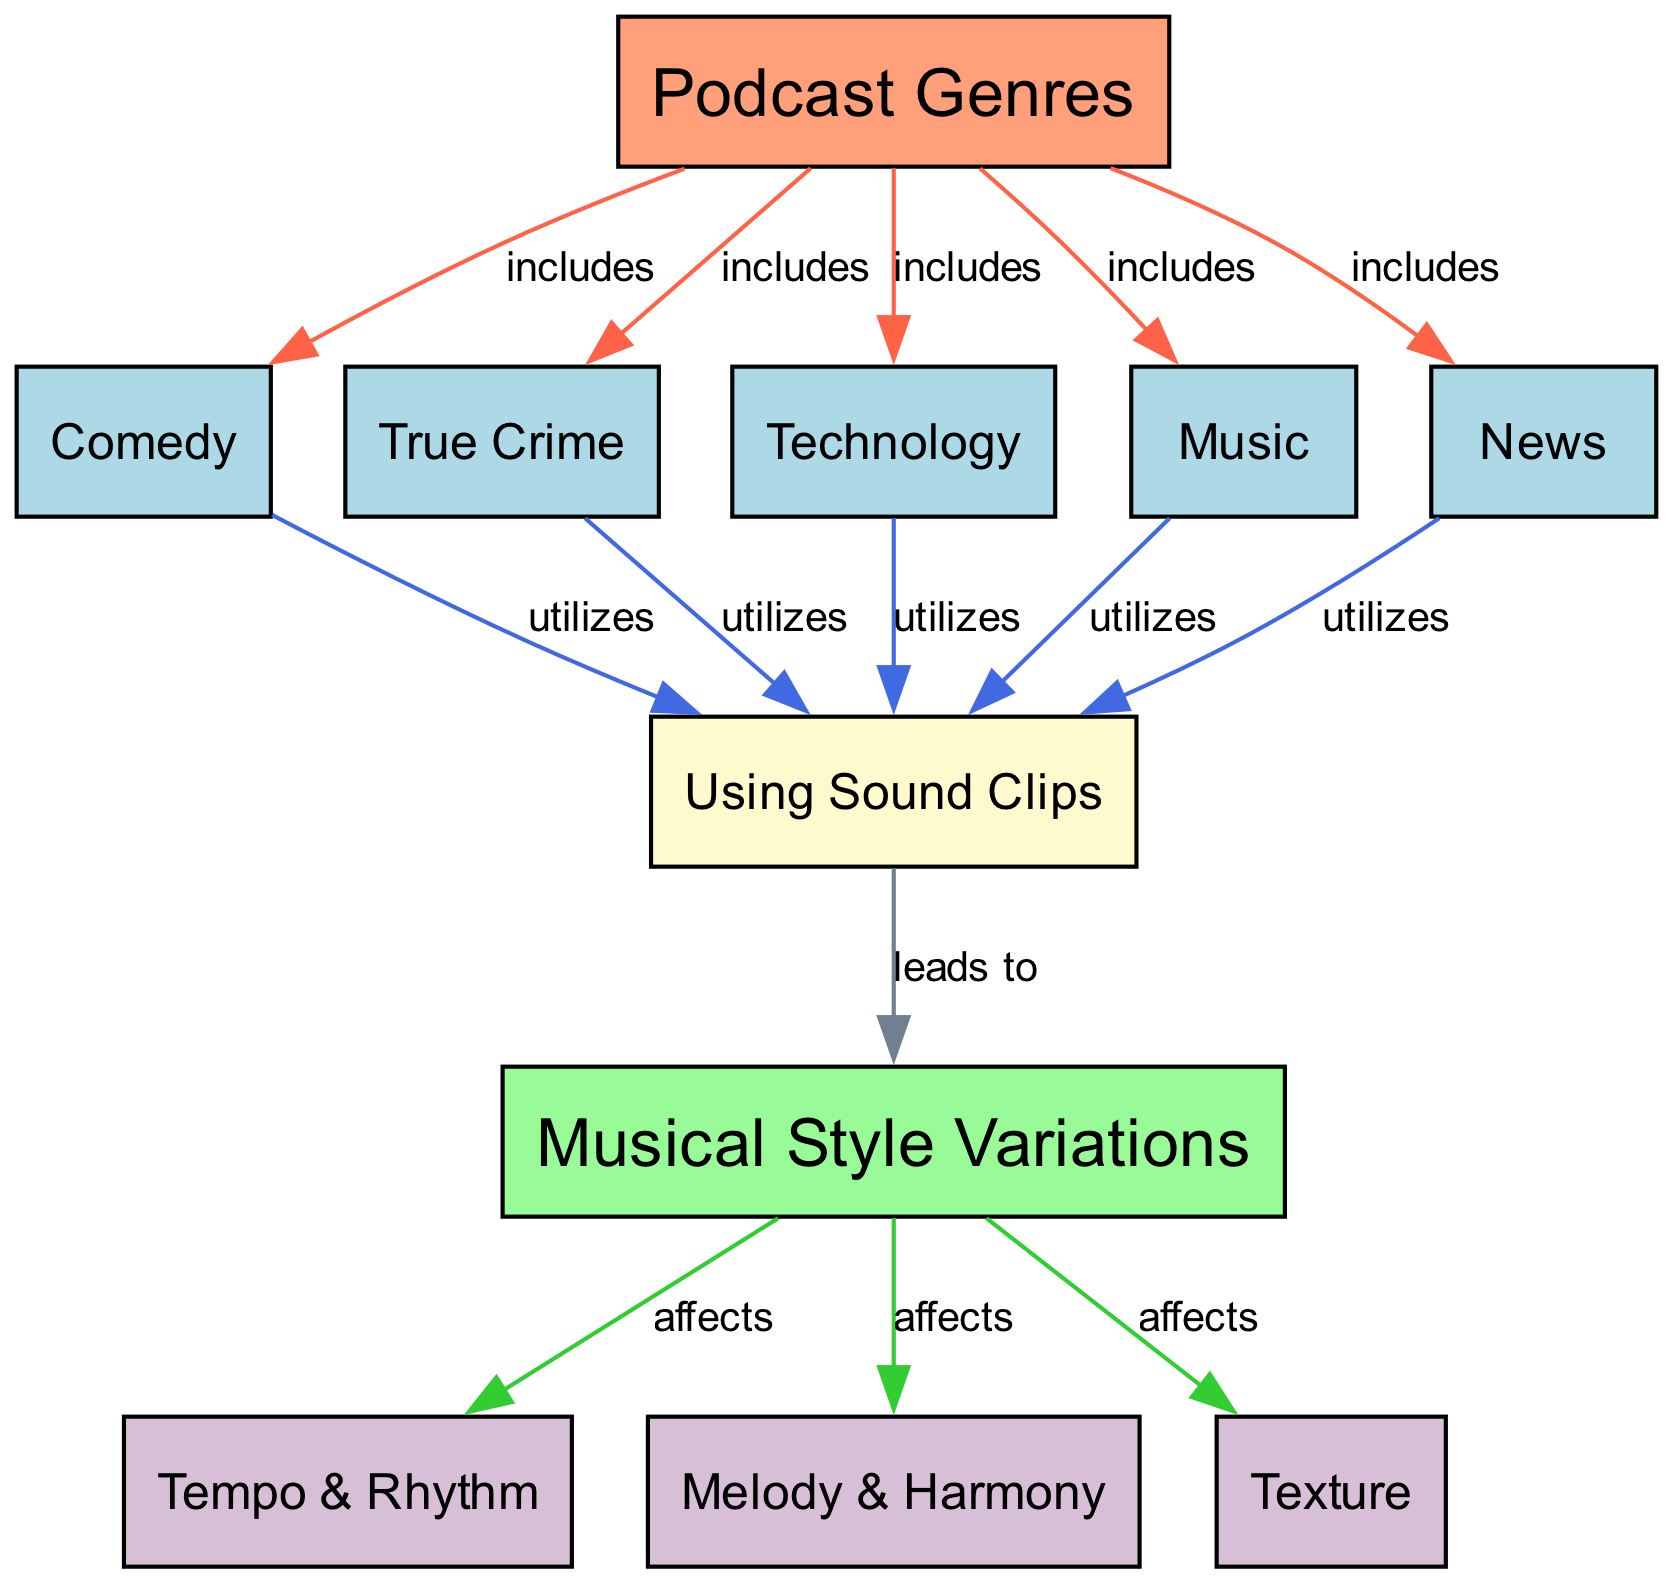What are the main podcast genres listed in the diagram? The diagram lists five main podcast genres, which are Comedy, True Crime, Technology, Music, and News. This information can be found in the nodes directly connected to the Podcast Genres node.
Answer: Comedy, True Crime, Technology, Music, News How many musical style variations are influenced by the podcast genres? There are three musical style variations: Tempo & Rhythm, Melody & Harmony, and Texture. These can be found in the nodes that are influenced by the Musical Style Variations node.
Answer: 3 Which podcast genre is linked to the usage of sound clips? All podcast genres listed (Comedy, True Crime, Technology, Music, News) lead to the Using Sound Clips node, indicating they utilize sound clips in their content.
Answer: All genres What is the relationship between podcast genres and musical style variations? The relationship is that different podcast genres can affect musical style variations through the use of sound clips, which leads to changes in Tempo & Rhythm, Melody & Harmony, and Texture. This can be identified by tracing the paths from podcast genres to Using Sound Clips and then to Musical Style Variations.
Answer: Affects How many unique edges connect the podcast genres to the using sound clips? There are five unique edges that connect each of the podcast genres (Comedy, True Crime, Technology, Music, and News) to the Using Sound Clips node. Each genre has a separate connection, making them all distinct.
Answer: 5 Which musical aspect is not directly influenced by podcast genres? There is no direct influence of podcast genres on any musical aspects without the intermediary of using sound clips. Therefore, any specific musical aspect like Tone or Pitch, which aren't represented in the diagram, would not be influenced.
Answer: Tone or Pitch What do the arrows between musical style variations indicate? The arrows between Musical Style Variations and Tempo & Rhythm, Melody & Harmony, and Texture indicate that these aspects are affected by the overall variations in music style. The arrows suggest a directional influence from the variations to these musical elements.
Answer: Affects Which genre is primarily associated with comedy in terms of using sound clips? The Comedy genre is specifically listed as utilizing sound clips, making it closely associated with audio snippets and their incorporation into musical pieces. It is one of the explicit genres connected to the Using Sound Clips node.
Answer: Comedy 